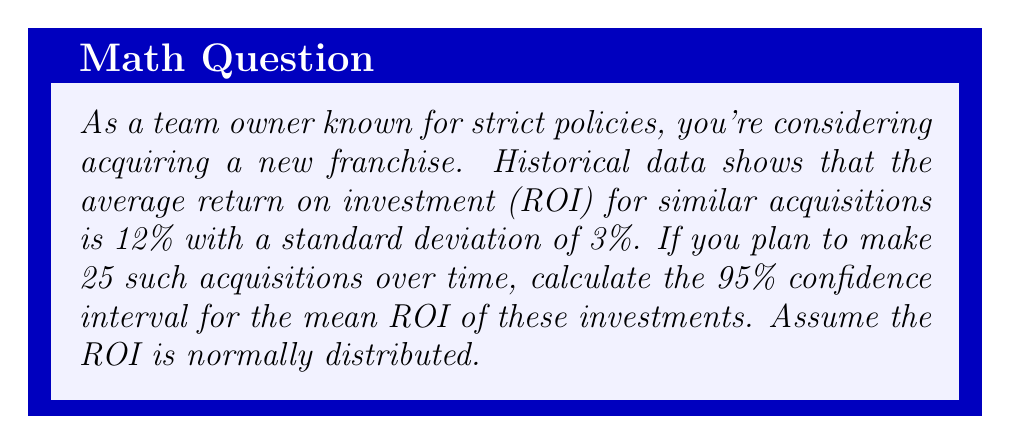Could you help me with this problem? To calculate the confidence interval, we'll follow these steps:

1) We're given:
   - Sample size: $n = 25$
   - Sample mean: $\bar{x} = 12\%$
   - Standard deviation: $s = 3\%$
   - Confidence level: 95% (α = 0.05)

2) For a 95% confidence interval, we use a z-score of 1.96 (from the standard normal distribution table).

3) The formula for the confidence interval is:

   $$\text{CI} = \bar{x} \pm z_{\alpha/2} \cdot \frac{s}{\sqrt{n}}$$

4) Substituting our values:

   $$\text{CI} = 12\% \pm 1.96 \cdot \frac{3\%}{\sqrt{25}}$$

5) Simplify:
   $$\text{CI} = 12\% \pm 1.96 \cdot \frac{3\%}{5}$$
   $$\text{CI} = 12\% \pm 1.96 \cdot 0.6\%$$
   $$\text{CI} = 12\% \pm 1.176\%$$

6) Calculate the lower and upper bounds:
   Lower bound: $12\% - 1.176\% = 10.824\%$
   Upper bound: $12\% + 1.176\% = 13.176\%$

Therefore, we can be 95% confident that the true mean ROI for these acquisitions lies between 10.824% and 13.176%.
Answer: (10.824%, 13.176%) 